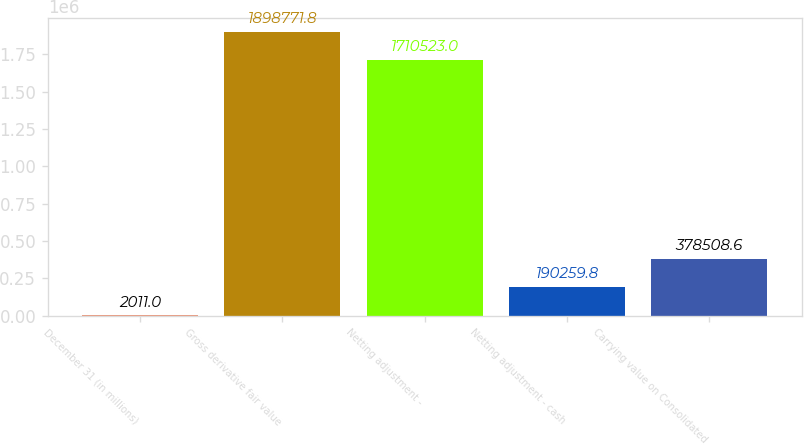Convert chart to OTSL. <chart><loc_0><loc_0><loc_500><loc_500><bar_chart><fcel>December 31 (in millions)<fcel>Gross derivative fair value<fcel>Netting adjustment -<fcel>Netting adjustment - cash<fcel>Carrying value on Consolidated<nl><fcel>2011<fcel>1.89877e+06<fcel>1.71052e+06<fcel>190260<fcel>378509<nl></chart> 